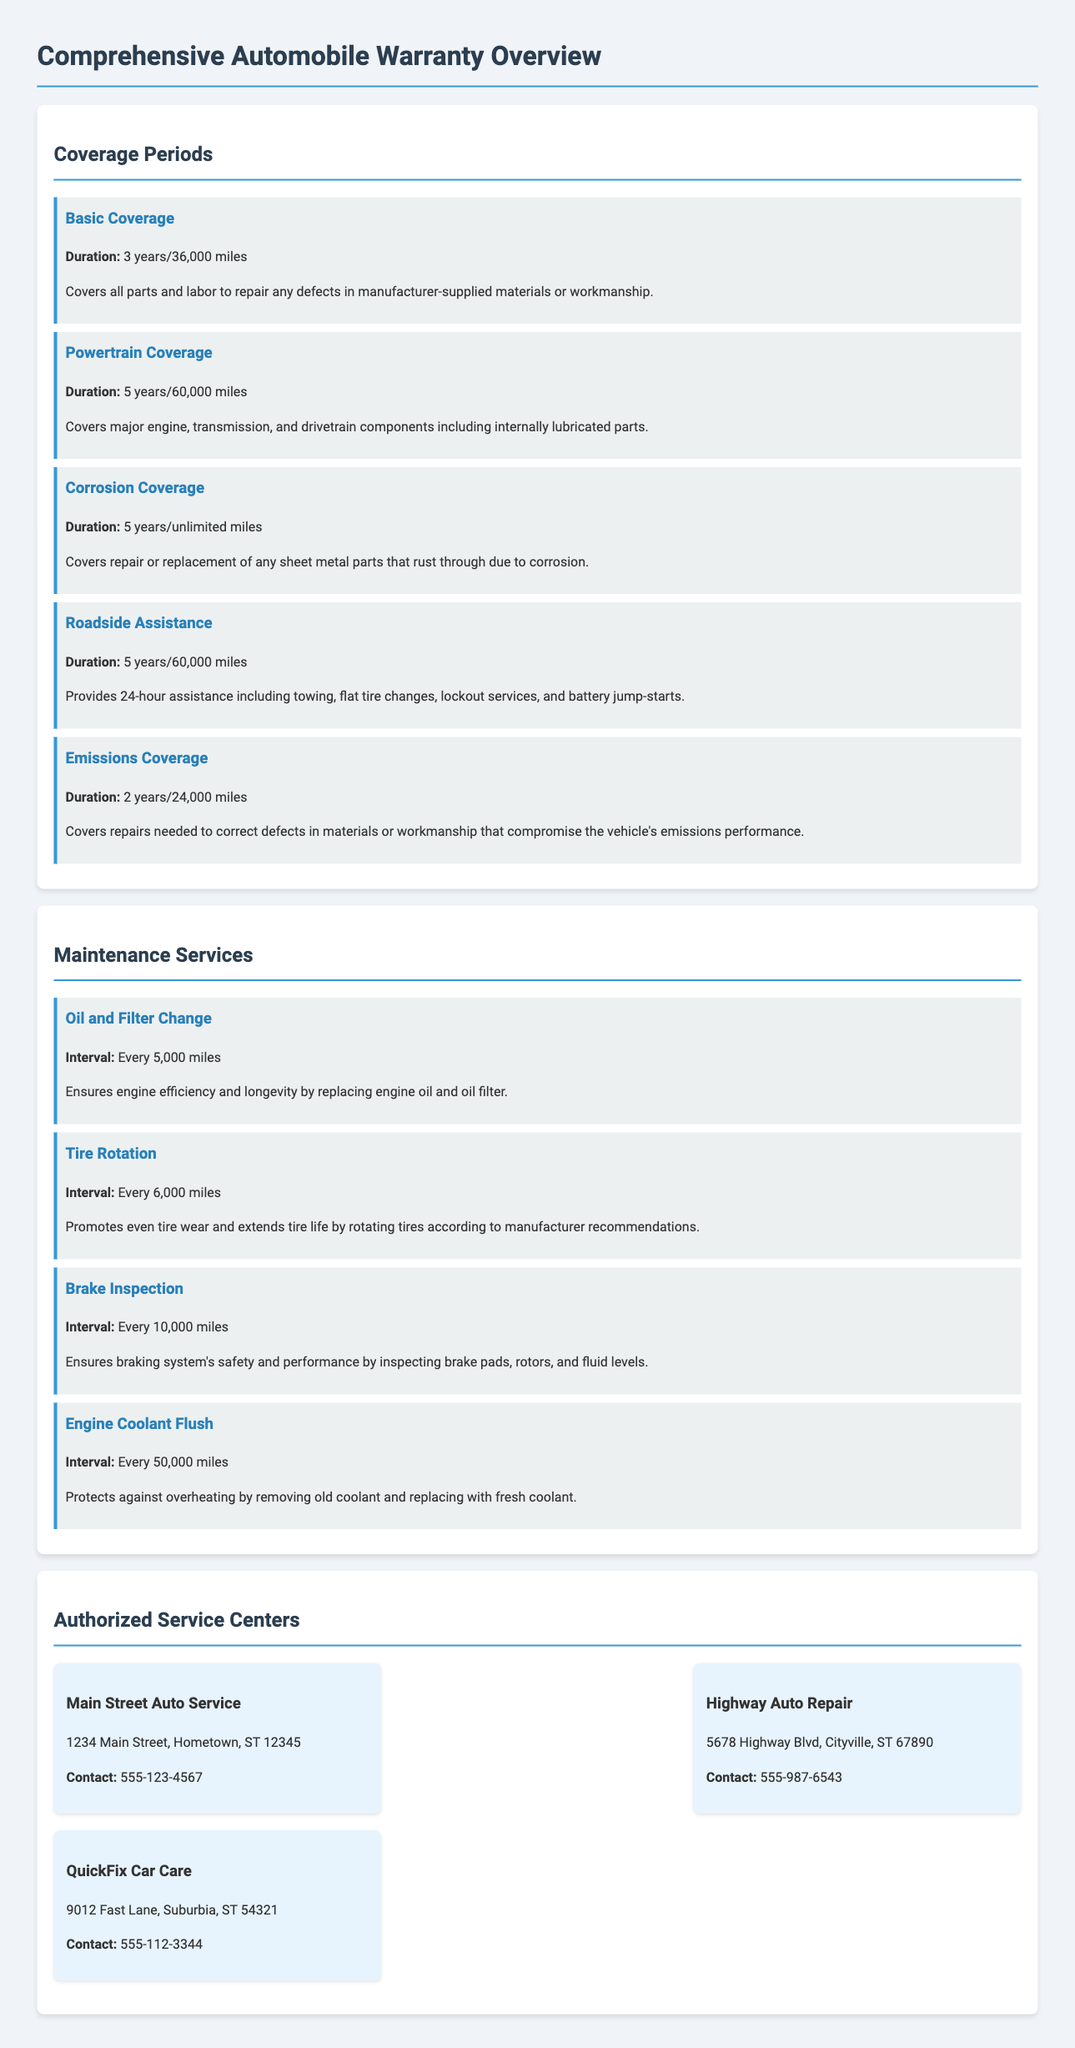What is the duration of Basic Coverage? Basic Coverage lasts for 3 years or 36,000 miles as mentioned in the document.
Answer: 3 years/36,000 miles What service is required every 5,000 miles? The document states that an Oil and Filter Change is required every 5,000 miles for maintenance.
Answer: Oil and Filter Change How long does Corrosion Coverage last? Corrosion Coverage lasts for 5 years with unlimited miles according to the document.
Answer: 5 years/unlimited miles What is the contact number for QuickFix Car Care? The document provides the contact number for QuickFix Car Care as 555-112-3344.
Answer: 555-112-3344 Which coverage involves towing assistance? The document indicates that Roadside Assistance coverage provides towing assistance as part of its services.
Answer: Roadside Assistance What interval is recommended for a Brake Inspection? The document states that Brake Inspection should be performed every 10,000 miles.
Answer: Every 10,000 miles How many service centers are listed in the document? The document lists three authorized service centers for warranty services.
Answer: Three What component does Powertrain Coverage specifically include? The document specifies that Powertrain Coverage includes major engine, transmission, and drivetrain components.
Answer: Major engine, transmission, and drivetrain components 